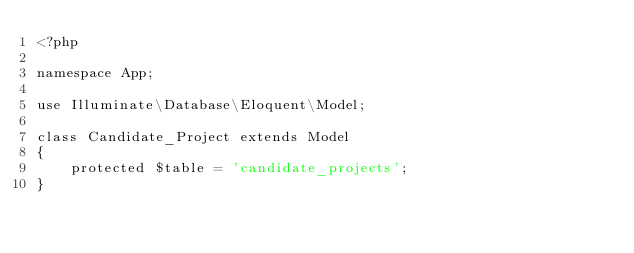<code> <loc_0><loc_0><loc_500><loc_500><_PHP_><?php

namespace App;

use Illuminate\Database\Eloquent\Model;

class Candidate_Project extends Model
{
    protected $table = 'candidate_projects';
}
</code> 